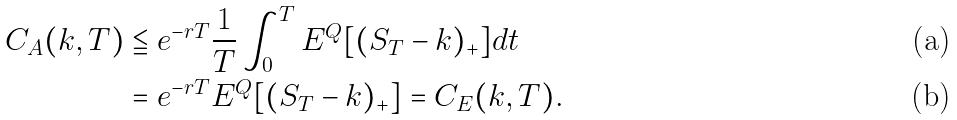<formula> <loc_0><loc_0><loc_500><loc_500>C _ { A } ( k , T ) & \leqq e ^ { - r T } \frac { 1 } { T } \int _ { 0 } ^ { T } E ^ { Q } [ ( S _ { T } - k ) _ { + } ] d t \\ & = e ^ { - r T } E ^ { Q } [ ( S _ { T } - k ) _ { + } ] = C _ { E } ( k , T ) .</formula> 